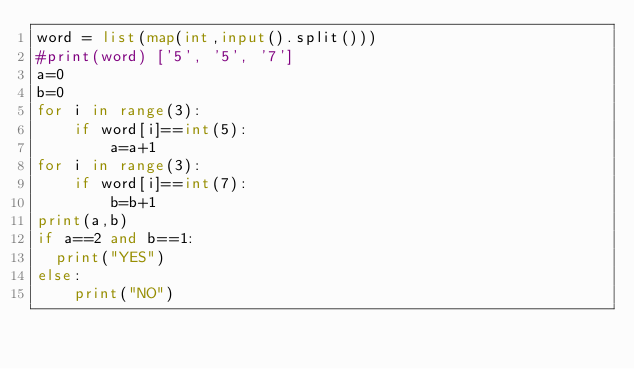Convert code to text. <code><loc_0><loc_0><loc_500><loc_500><_Python_>word = list(map(int,input().split()))
#print(word) ['5', '5', '7']
a=0
b=0
for i in range(3):
    if word[i]==int(5):
        a=a+1
for i in range(3):
    if word[i]==int(7):
        b=b+1
print(a,b)
if a==2 and b==1:
	print("YES")
else:
  	print("NO")
</code> 